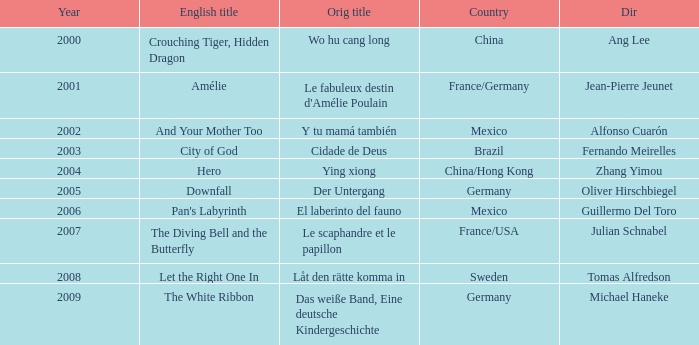Tell me the country for julian schnabel France/USA. 